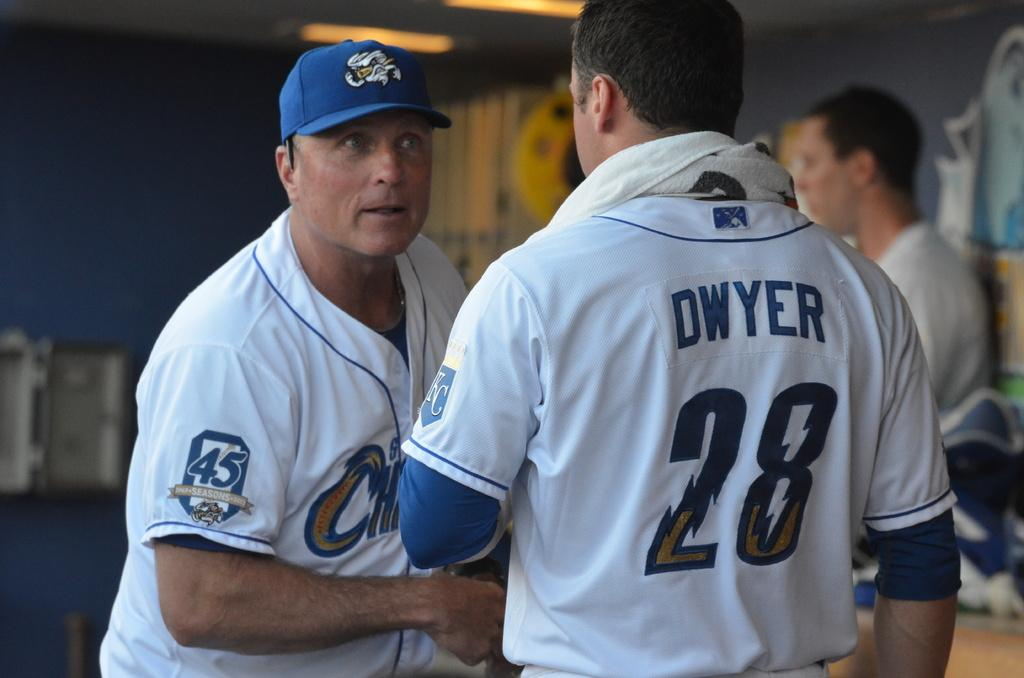<image>
Provide a brief description of the given image. Two baseball players talking, one with a shirt that says Dwyer on the back. 